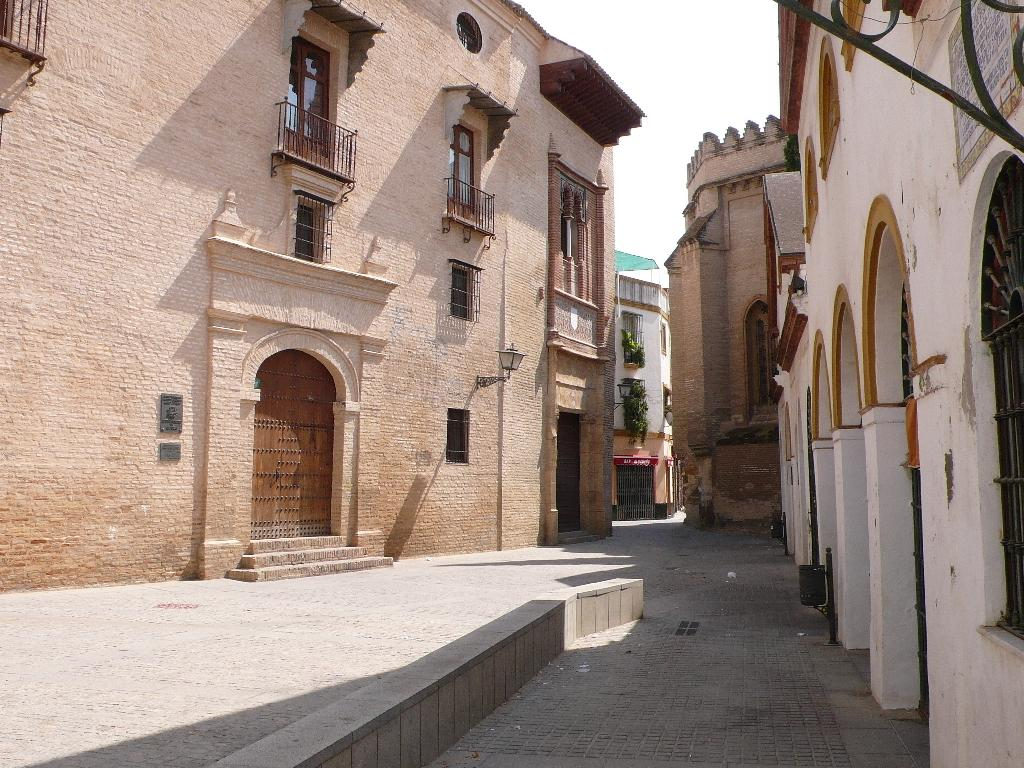What type of structures can be seen in the image? There are buildings in the image. What architectural features are visible on the buildings? There are windows and doors visible on the buildings. What type of barrier is present in the image? There is a fence in the image. What type of vegetation is present in the image? There are houseplants in the image. What part of the natural environment is visible in the image? The sky is visible in the image. Based on the presence of the sky and the absence of artificial lighting, when do you think the image was likely taken? The image was likely taken during the day. Who is the creator of the group of buildings in the image? There is no information about the creator of the buildings in the image. What is the tax rate for the houseplants in the image? There is no information about tax rates for houseplants in the image. 